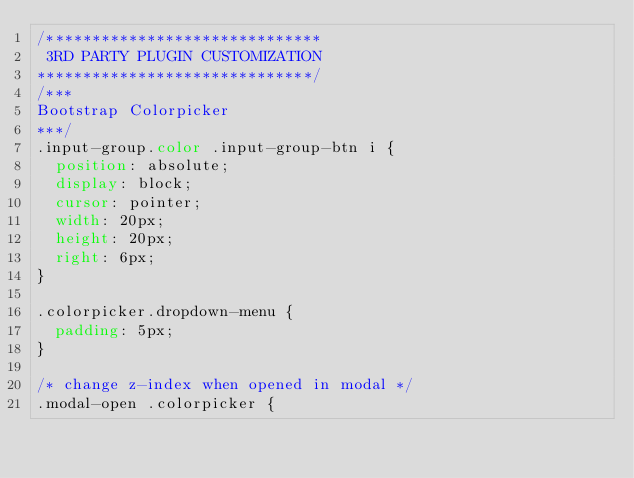<code> <loc_0><loc_0><loc_500><loc_500><_CSS_>/******************************
 3RD PARTY PLUGIN CUSTOMIZATION 
******************************/
/***
Bootstrap Colorpicker
***/
.input-group.color .input-group-btn i {
  position: absolute;
  display: block;
  cursor: pointer;
  width: 20px;
  height: 20px;
  right: 6px;
}

.colorpicker.dropdown-menu {
  padding: 5px;
}

/* change z-index when opened in modal */
.modal-open .colorpicker {</code> 